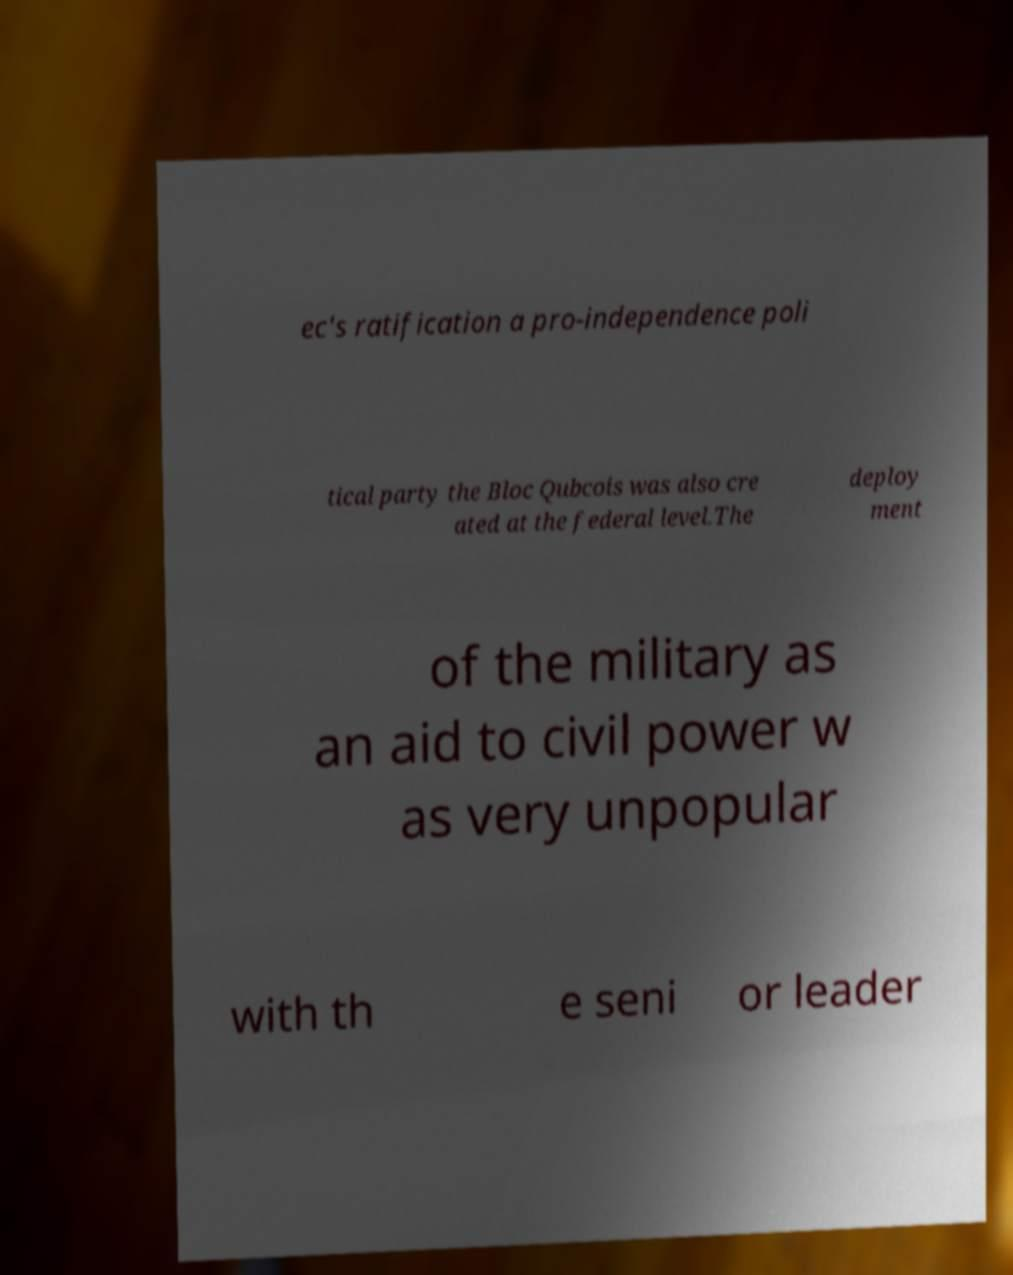Could you assist in decoding the text presented in this image and type it out clearly? ec's ratification a pro-independence poli tical party the Bloc Qubcois was also cre ated at the federal level.The deploy ment of the military as an aid to civil power w as very unpopular with th e seni or leader 